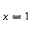<formula> <loc_0><loc_0><loc_500><loc_500>x = 1</formula> 